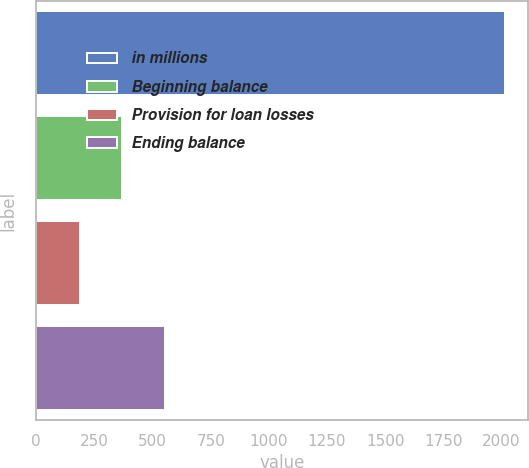<chart> <loc_0><loc_0><loc_500><loc_500><bar_chart><fcel>in millions<fcel>Beginning balance<fcel>Provision for loan losses<fcel>Ending balance<nl><fcel>2015<fcel>369.8<fcel>187<fcel>552.6<nl></chart> 